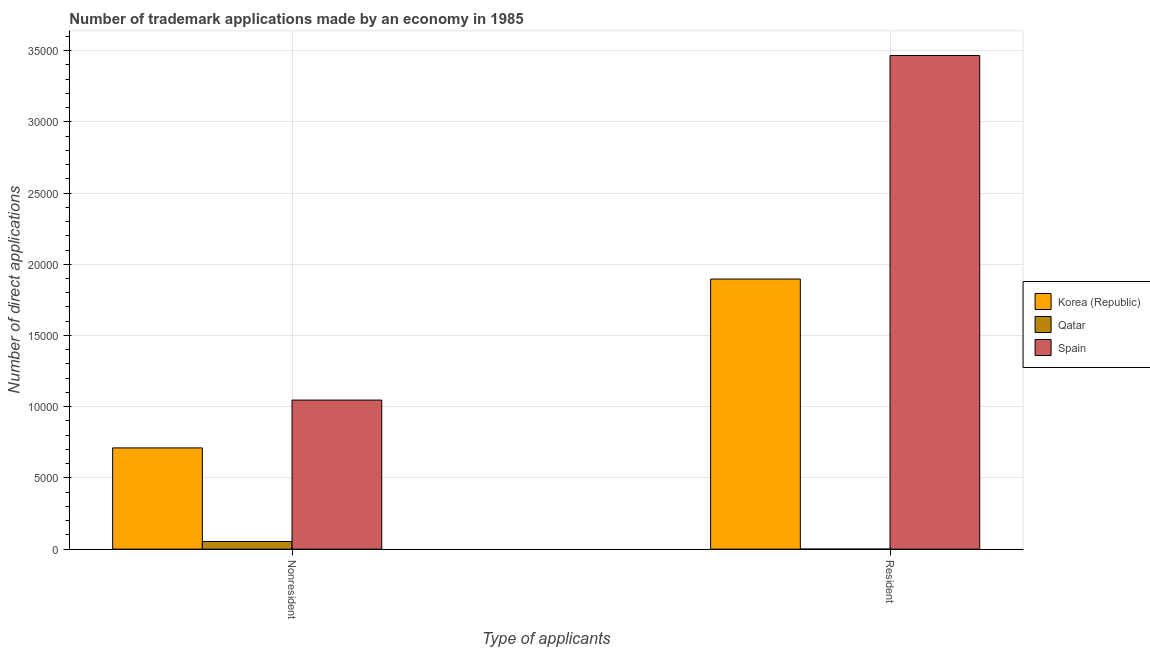How many different coloured bars are there?
Offer a terse response. 3. How many groups of bars are there?
Your answer should be very brief. 2. Are the number of bars on each tick of the X-axis equal?
Offer a very short reply. Yes. How many bars are there on the 2nd tick from the left?
Your response must be concise. 3. What is the label of the 1st group of bars from the left?
Make the answer very short. Nonresident. What is the number of trademark applications made by non residents in Spain?
Your answer should be compact. 1.05e+04. Across all countries, what is the maximum number of trademark applications made by residents?
Your answer should be compact. 3.47e+04. Across all countries, what is the minimum number of trademark applications made by residents?
Provide a short and direct response. 4. In which country was the number of trademark applications made by non residents minimum?
Your answer should be compact. Qatar. What is the total number of trademark applications made by residents in the graph?
Your answer should be compact. 5.36e+04. What is the difference between the number of trademark applications made by non residents in Korea (Republic) and that in Spain?
Your response must be concise. -3358. What is the difference between the number of trademark applications made by non residents in Spain and the number of trademark applications made by residents in Korea (Republic)?
Make the answer very short. -8497. What is the average number of trademark applications made by residents per country?
Offer a very short reply. 1.79e+04. What is the difference between the number of trademark applications made by residents and number of trademark applications made by non residents in Qatar?
Offer a terse response. -534. In how many countries, is the number of trademark applications made by residents greater than 5000 ?
Offer a terse response. 2. What is the ratio of the number of trademark applications made by residents in Spain to that in Korea (Republic)?
Keep it short and to the point. 1.83. Is the number of trademark applications made by non residents in Qatar less than that in Spain?
Offer a very short reply. Yes. What does the 3rd bar from the left in Nonresident represents?
Your answer should be very brief. Spain. What does the 2nd bar from the right in Resident represents?
Offer a terse response. Qatar. Are all the bars in the graph horizontal?
Provide a succinct answer. No. Are the values on the major ticks of Y-axis written in scientific E-notation?
Give a very brief answer. No. Does the graph contain any zero values?
Give a very brief answer. No. Where does the legend appear in the graph?
Ensure brevity in your answer.  Center right. What is the title of the graph?
Ensure brevity in your answer.  Number of trademark applications made by an economy in 1985. Does "Liechtenstein" appear as one of the legend labels in the graph?
Ensure brevity in your answer.  No. What is the label or title of the X-axis?
Ensure brevity in your answer.  Type of applicants. What is the label or title of the Y-axis?
Your response must be concise. Number of direct applications. What is the Number of direct applications of Korea (Republic) in Nonresident?
Provide a succinct answer. 7107. What is the Number of direct applications in Qatar in Nonresident?
Provide a succinct answer. 538. What is the Number of direct applications of Spain in Nonresident?
Offer a very short reply. 1.05e+04. What is the Number of direct applications in Korea (Republic) in Resident?
Provide a succinct answer. 1.90e+04. What is the Number of direct applications of Spain in Resident?
Ensure brevity in your answer.  3.47e+04. Across all Type of applicants, what is the maximum Number of direct applications in Korea (Republic)?
Provide a succinct answer. 1.90e+04. Across all Type of applicants, what is the maximum Number of direct applications in Qatar?
Ensure brevity in your answer.  538. Across all Type of applicants, what is the maximum Number of direct applications in Spain?
Provide a succinct answer. 3.47e+04. Across all Type of applicants, what is the minimum Number of direct applications in Korea (Republic)?
Keep it short and to the point. 7107. Across all Type of applicants, what is the minimum Number of direct applications in Qatar?
Your response must be concise. 4. Across all Type of applicants, what is the minimum Number of direct applications in Spain?
Give a very brief answer. 1.05e+04. What is the total Number of direct applications of Korea (Republic) in the graph?
Give a very brief answer. 2.61e+04. What is the total Number of direct applications of Qatar in the graph?
Provide a short and direct response. 542. What is the total Number of direct applications of Spain in the graph?
Make the answer very short. 4.51e+04. What is the difference between the Number of direct applications of Korea (Republic) in Nonresident and that in Resident?
Ensure brevity in your answer.  -1.19e+04. What is the difference between the Number of direct applications of Qatar in Nonresident and that in Resident?
Your answer should be very brief. 534. What is the difference between the Number of direct applications of Spain in Nonresident and that in Resident?
Make the answer very short. -2.42e+04. What is the difference between the Number of direct applications in Korea (Republic) in Nonresident and the Number of direct applications in Qatar in Resident?
Make the answer very short. 7103. What is the difference between the Number of direct applications in Korea (Republic) in Nonresident and the Number of direct applications in Spain in Resident?
Give a very brief answer. -2.75e+04. What is the difference between the Number of direct applications of Qatar in Nonresident and the Number of direct applications of Spain in Resident?
Offer a very short reply. -3.41e+04. What is the average Number of direct applications of Korea (Republic) per Type of applicants?
Your answer should be compact. 1.30e+04. What is the average Number of direct applications of Qatar per Type of applicants?
Your answer should be very brief. 271. What is the average Number of direct applications in Spain per Type of applicants?
Ensure brevity in your answer.  2.26e+04. What is the difference between the Number of direct applications in Korea (Republic) and Number of direct applications in Qatar in Nonresident?
Your answer should be compact. 6569. What is the difference between the Number of direct applications of Korea (Republic) and Number of direct applications of Spain in Nonresident?
Your response must be concise. -3358. What is the difference between the Number of direct applications of Qatar and Number of direct applications of Spain in Nonresident?
Give a very brief answer. -9927. What is the difference between the Number of direct applications of Korea (Republic) and Number of direct applications of Qatar in Resident?
Ensure brevity in your answer.  1.90e+04. What is the difference between the Number of direct applications of Korea (Republic) and Number of direct applications of Spain in Resident?
Ensure brevity in your answer.  -1.57e+04. What is the difference between the Number of direct applications of Qatar and Number of direct applications of Spain in Resident?
Offer a very short reply. -3.47e+04. What is the ratio of the Number of direct applications of Korea (Republic) in Nonresident to that in Resident?
Keep it short and to the point. 0.37. What is the ratio of the Number of direct applications of Qatar in Nonresident to that in Resident?
Provide a succinct answer. 134.5. What is the ratio of the Number of direct applications in Spain in Nonresident to that in Resident?
Provide a short and direct response. 0.3. What is the difference between the highest and the second highest Number of direct applications in Korea (Republic)?
Offer a very short reply. 1.19e+04. What is the difference between the highest and the second highest Number of direct applications of Qatar?
Offer a very short reply. 534. What is the difference between the highest and the second highest Number of direct applications in Spain?
Offer a terse response. 2.42e+04. What is the difference between the highest and the lowest Number of direct applications of Korea (Republic)?
Offer a very short reply. 1.19e+04. What is the difference between the highest and the lowest Number of direct applications in Qatar?
Keep it short and to the point. 534. What is the difference between the highest and the lowest Number of direct applications in Spain?
Ensure brevity in your answer.  2.42e+04. 